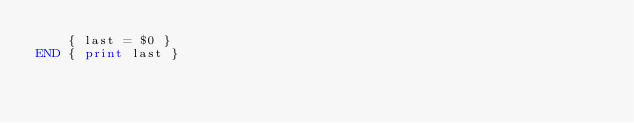Convert code to text. <code><loc_0><loc_0><loc_500><loc_500><_Awk_>    { last = $0 }
END { print last }
</code> 